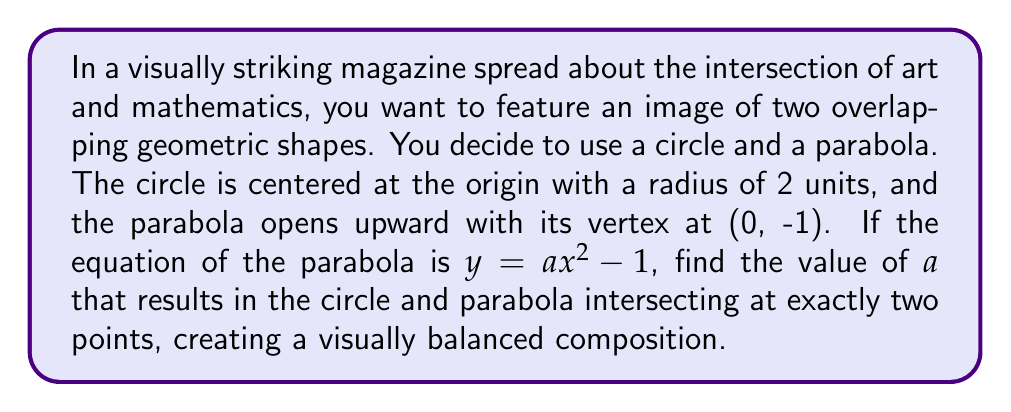Could you help me with this problem? Let's approach this step-by-step:

1) The equation of the circle with radius 2 centered at the origin is:
   $$x^2 + y^2 = 4$$

2) The equation of the parabola is:
   $$y = ax^2 - 1$$

3) To find the intersection points, we substitute the parabola equation into the circle equation:
   $$x^2 + (ax^2 - 1)^2 = 4$$

4) Expand this:
   $$x^2 + a^2x^4 - 2ax^2 + 1 = 4$$

5) Rearrange:
   $$a^2x^4 + (1-2a)x^2 - 3 = 0$$

6) For the circle and parabola to intersect at exactly two points, this equation should have exactly two solutions. This occurs when the discriminant of this quadratic equation (in terms of $x^2$) is zero.

7) The discriminant of $Ax^2 + Bx + C = 0$ is $B^2 - 4AC$. Here, $A = a^2$, $B = 1-2a$, and $C = -3$.

8) Set up the discriminant equation:
   $$(1-2a)^2 - 4(a^2)(-3) = 0$$

9) Expand:
   $$1 - 4a + 4a^2 + 12a^2 = 0$$
   $$16a^2 - 4a + 1 = 0$$

10) This is a quadratic in $a$. Solve using the quadratic formula:
    $$a = \frac{4 \pm \sqrt{16 - 64}}{32} = \frac{4 \pm \sqrt{-48}}{32}$$

11) Since we need a real solution, the only valid option is:
    $$a = \frac{4}{32} = \frac{1}{8} = 0.125$$

[asy]
import graph;
size(200);
real f(real x) {return 0.125x^2 - 1;}
draw(circle((0,0), 2));
draw(graph(f, -4, 4));
draw((-4,0)--(4,0), arrow=Arrow);
draw((0,-3)--(0,3), arrow=Arrow);
label("x", (4,0), E);
label("y", (0,3), N);
[/asy]
Answer: $a = \frac{1}{8}$ or $0.125$ 